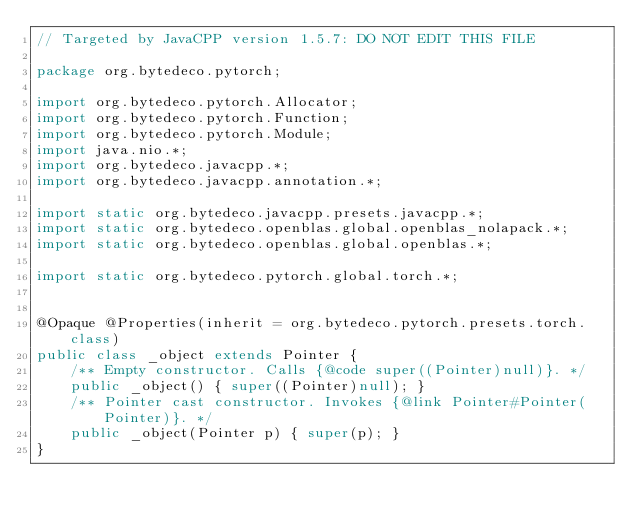<code> <loc_0><loc_0><loc_500><loc_500><_Java_>// Targeted by JavaCPP version 1.5.7: DO NOT EDIT THIS FILE

package org.bytedeco.pytorch;

import org.bytedeco.pytorch.Allocator;
import org.bytedeco.pytorch.Function;
import org.bytedeco.pytorch.Module;
import java.nio.*;
import org.bytedeco.javacpp.*;
import org.bytedeco.javacpp.annotation.*;

import static org.bytedeco.javacpp.presets.javacpp.*;
import static org.bytedeco.openblas.global.openblas_nolapack.*;
import static org.bytedeco.openblas.global.openblas.*;

import static org.bytedeco.pytorch.global.torch.*;


@Opaque @Properties(inherit = org.bytedeco.pytorch.presets.torch.class)
public class _object extends Pointer {
    /** Empty constructor. Calls {@code super((Pointer)null)}. */
    public _object() { super((Pointer)null); }
    /** Pointer cast constructor. Invokes {@link Pointer#Pointer(Pointer)}. */
    public _object(Pointer p) { super(p); }
}
</code> 